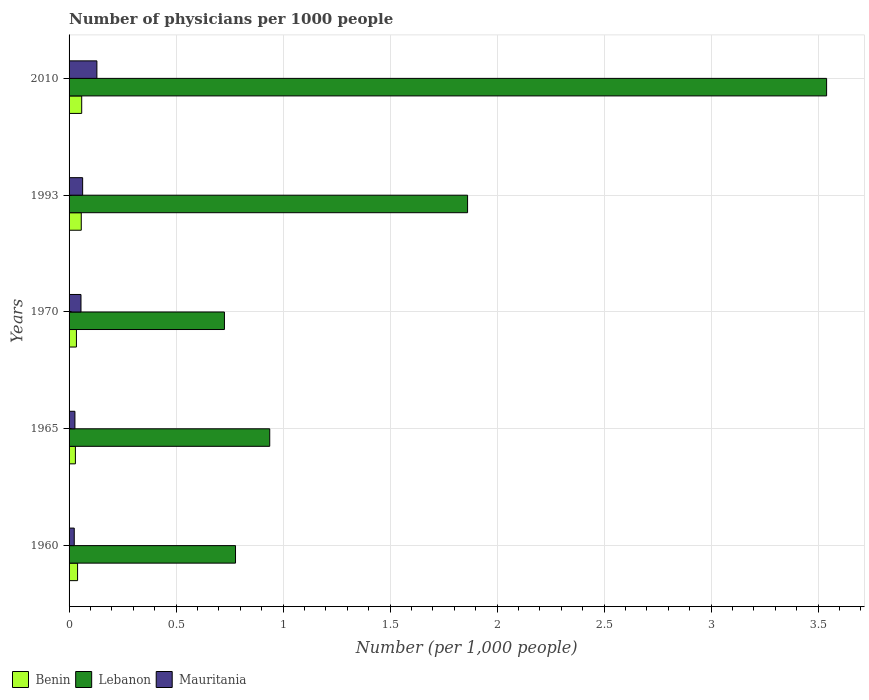How many groups of bars are there?
Give a very brief answer. 5. Are the number of bars per tick equal to the number of legend labels?
Provide a succinct answer. Yes. How many bars are there on the 5th tick from the bottom?
Ensure brevity in your answer.  3. What is the number of physicians in Mauritania in 1970?
Make the answer very short. 0.06. Across all years, what is the maximum number of physicians in Lebanon?
Your answer should be very brief. 3.54. Across all years, what is the minimum number of physicians in Benin?
Ensure brevity in your answer.  0.03. What is the total number of physicians in Mauritania in the graph?
Your answer should be very brief. 0.3. What is the difference between the number of physicians in Mauritania in 1965 and that in 1970?
Ensure brevity in your answer.  -0.03. What is the difference between the number of physicians in Mauritania in 1970 and the number of physicians in Lebanon in 1960?
Your answer should be compact. -0.72. What is the average number of physicians in Lebanon per year?
Your response must be concise. 1.57. In the year 1960, what is the difference between the number of physicians in Benin and number of physicians in Lebanon?
Offer a very short reply. -0.74. What is the ratio of the number of physicians in Mauritania in 1960 to that in 2010?
Ensure brevity in your answer.  0.19. What is the difference between the highest and the second highest number of physicians in Lebanon?
Give a very brief answer. 1.68. What is the difference between the highest and the lowest number of physicians in Benin?
Offer a terse response. 0.03. What does the 2nd bar from the top in 1960 represents?
Offer a very short reply. Lebanon. What does the 1st bar from the bottom in 2010 represents?
Keep it short and to the point. Benin. Is it the case that in every year, the sum of the number of physicians in Mauritania and number of physicians in Benin is greater than the number of physicians in Lebanon?
Your answer should be compact. No. How many bars are there?
Provide a short and direct response. 15. Are all the bars in the graph horizontal?
Provide a short and direct response. Yes. How many years are there in the graph?
Offer a terse response. 5. Are the values on the major ticks of X-axis written in scientific E-notation?
Give a very brief answer. No. Does the graph contain grids?
Offer a very short reply. Yes. How are the legend labels stacked?
Your response must be concise. Horizontal. What is the title of the graph?
Your response must be concise. Number of physicians per 1000 people. What is the label or title of the X-axis?
Provide a succinct answer. Number (per 1,0 people). What is the Number (per 1,000 people) of Benin in 1960?
Your answer should be compact. 0.04. What is the Number (per 1,000 people) of Lebanon in 1960?
Offer a terse response. 0.78. What is the Number (per 1,000 people) of Mauritania in 1960?
Provide a short and direct response. 0.02. What is the Number (per 1,000 people) of Benin in 1965?
Offer a terse response. 0.03. What is the Number (per 1,000 people) of Lebanon in 1965?
Your answer should be compact. 0.94. What is the Number (per 1,000 people) of Mauritania in 1965?
Provide a short and direct response. 0.03. What is the Number (per 1,000 people) in Benin in 1970?
Your response must be concise. 0.03. What is the Number (per 1,000 people) of Lebanon in 1970?
Make the answer very short. 0.73. What is the Number (per 1,000 people) in Mauritania in 1970?
Keep it short and to the point. 0.06. What is the Number (per 1,000 people) of Benin in 1993?
Your response must be concise. 0.06. What is the Number (per 1,000 people) of Lebanon in 1993?
Provide a succinct answer. 1.86. What is the Number (per 1,000 people) in Mauritania in 1993?
Give a very brief answer. 0.06. What is the Number (per 1,000 people) of Benin in 2010?
Your response must be concise. 0.06. What is the Number (per 1,000 people) of Lebanon in 2010?
Your answer should be very brief. 3.54. What is the Number (per 1,000 people) of Mauritania in 2010?
Your answer should be compact. 0.13. Across all years, what is the maximum Number (per 1,000 people) of Benin?
Ensure brevity in your answer.  0.06. Across all years, what is the maximum Number (per 1,000 people) of Lebanon?
Your answer should be very brief. 3.54. Across all years, what is the maximum Number (per 1,000 people) in Mauritania?
Ensure brevity in your answer.  0.13. Across all years, what is the minimum Number (per 1,000 people) of Benin?
Your answer should be very brief. 0.03. Across all years, what is the minimum Number (per 1,000 people) in Lebanon?
Keep it short and to the point. 0.73. Across all years, what is the minimum Number (per 1,000 people) of Mauritania?
Your response must be concise. 0.02. What is the total Number (per 1,000 people) in Benin in the graph?
Your answer should be compact. 0.22. What is the total Number (per 1,000 people) of Lebanon in the graph?
Offer a very short reply. 7.84. What is the total Number (per 1,000 people) in Mauritania in the graph?
Your response must be concise. 0.3. What is the difference between the Number (per 1,000 people) of Benin in 1960 and that in 1965?
Give a very brief answer. 0.01. What is the difference between the Number (per 1,000 people) in Lebanon in 1960 and that in 1965?
Make the answer very short. -0.16. What is the difference between the Number (per 1,000 people) in Mauritania in 1960 and that in 1965?
Offer a very short reply. -0. What is the difference between the Number (per 1,000 people) of Benin in 1960 and that in 1970?
Your answer should be compact. 0.01. What is the difference between the Number (per 1,000 people) in Lebanon in 1960 and that in 1970?
Your answer should be very brief. 0.05. What is the difference between the Number (per 1,000 people) of Mauritania in 1960 and that in 1970?
Ensure brevity in your answer.  -0.03. What is the difference between the Number (per 1,000 people) in Benin in 1960 and that in 1993?
Your response must be concise. -0.02. What is the difference between the Number (per 1,000 people) of Lebanon in 1960 and that in 1993?
Your answer should be very brief. -1.08. What is the difference between the Number (per 1,000 people) of Mauritania in 1960 and that in 1993?
Give a very brief answer. -0.04. What is the difference between the Number (per 1,000 people) in Benin in 1960 and that in 2010?
Your answer should be very brief. -0.02. What is the difference between the Number (per 1,000 people) of Lebanon in 1960 and that in 2010?
Give a very brief answer. -2.76. What is the difference between the Number (per 1,000 people) of Mauritania in 1960 and that in 2010?
Your answer should be compact. -0.11. What is the difference between the Number (per 1,000 people) of Benin in 1965 and that in 1970?
Your answer should be compact. -0. What is the difference between the Number (per 1,000 people) in Lebanon in 1965 and that in 1970?
Your answer should be very brief. 0.21. What is the difference between the Number (per 1,000 people) in Mauritania in 1965 and that in 1970?
Your answer should be very brief. -0.03. What is the difference between the Number (per 1,000 people) in Benin in 1965 and that in 1993?
Ensure brevity in your answer.  -0.03. What is the difference between the Number (per 1,000 people) of Lebanon in 1965 and that in 1993?
Provide a succinct answer. -0.92. What is the difference between the Number (per 1,000 people) of Mauritania in 1965 and that in 1993?
Provide a succinct answer. -0.04. What is the difference between the Number (per 1,000 people) in Benin in 1965 and that in 2010?
Your answer should be compact. -0.03. What is the difference between the Number (per 1,000 people) of Lebanon in 1965 and that in 2010?
Make the answer very short. -2.6. What is the difference between the Number (per 1,000 people) in Mauritania in 1965 and that in 2010?
Offer a terse response. -0.1. What is the difference between the Number (per 1,000 people) of Benin in 1970 and that in 1993?
Give a very brief answer. -0.02. What is the difference between the Number (per 1,000 people) of Lebanon in 1970 and that in 1993?
Provide a short and direct response. -1.14. What is the difference between the Number (per 1,000 people) of Mauritania in 1970 and that in 1993?
Ensure brevity in your answer.  -0.01. What is the difference between the Number (per 1,000 people) of Benin in 1970 and that in 2010?
Give a very brief answer. -0.02. What is the difference between the Number (per 1,000 people) in Lebanon in 1970 and that in 2010?
Keep it short and to the point. -2.81. What is the difference between the Number (per 1,000 people) in Mauritania in 1970 and that in 2010?
Keep it short and to the point. -0.07. What is the difference between the Number (per 1,000 people) in Benin in 1993 and that in 2010?
Your response must be concise. -0. What is the difference between the Number (per 1,000 people) of Lebanon in 1993 and that in 2010?
Make the answer very short. -1.68. What is the difference between the Number (per 1,000 people) in Mauritania in 1993 and that in 2010?
Your answer should be very brief. -0.07. What is the difference between the Number (per 1,000 people) in Benin in 1960 and the Number (per 1,000 people) in Lebanon in 1965?
Provide a short and direct response. -0.9. What is the difference between the Number (per 1,000 people) in Benin in 1960 and the Number (per 1,000 people) in Mauritania in 1965?
Make the answer very short. 0.01. What is the difference between the Number (per 1,000 people) in Lebanon in 1960 and the Number (per 1,000 people) in Mauritania in 1965?
Ensure brevity in your answer.  0.75. What is the difference between the Number (per 1,000 people) in Benin in 1960 and the Number (per 1,000 people) in Lebanon in 1970?
Ensure brevity in your answer.  -0.69. What is the difference between the Number (per 1,000 people) in Benin in 1960 and the Number (per 1,000 people) in Mauritania in 1970?
Your answer should be very brief. -0.02. What is the difference between the Number (per 1,000 people) in Lebanon in 1960 and the Number (per 1,000 people) in Mauritania in 1970?
Make the answer very short. 0.72. What is the difference between the Number (per 1,000 people) in Benin in 1960 and the Number (per 1,000 people) in Lebanon in 1993?
Ensure brevity in your answer.  -1.82. What is the difference between the Number (per 1,000 people) in Benin in 1960 and the Number (per 1,000 people) in Mauritania in 1993?
Your response must be concise. -0.02. What is the difference between the Number (per 1,000 people) of Lebanon in 1960 and the Number (per 1,000 people) of Mauritania in 1993?
Provide a succinct answer. 0.71. What is the difference between the Number (per 1,000 people) in Benin in 1960 and the Number (per 1,000 people) in Lebanon in 2010?
Your answer should be very brief. -3.5. What is the difference between the Number (per 1,000 people) of Benin in 1960 and the Number (per 1,000 people) of Mauritania in 2010?
Keep it short and to the point. -0.09. What is the difference between the Number (per 1,000 people) in Lebanon in 1960 and the Number (per 1,000 people) in Mauritania in 2010?
Offer a very short reply. 0.65. What is the difference between the Number (per 1,000 people) in Benin in 1965 and the Number (per 1,000 people) in Lebanon in 1970?
Offer a terse response. -0.7. What is the difference between the Number (per 1,000 people) in Benin in 1965 and the Number (per 1,000 people) in Mauritania in 1970?
Ensure brevity in your answer.  -0.03. What is the difference between the Number (per 1,000 people) in Lebanon in 1965 and the Number (per 1,000 people) in Mauritania in 1970?
Provide a succinct answer. 0.88. What is the difference between the Number (per 1,000 people) in Benin in 1965 and the Number (per 1,000 people) in Lebanon in 1993?
Your answer should be very brief. -1.83. What is the difference between the Number (per 1,000 people) of Benin in 1965 and the Number (per 1,000 people) of Mauritania in 1993?
Your response must be concise. -0.03. What is the difference between the Number (per 1,000 people) of Lebanon in 1965 and the Number (per 1,000 people) of Mauritania in 1993?
Provide a short and direct response. 0.87. What is the difference between the Number (per 1,000 people) of Benin in 1965 and the Number (per 1,000 people) of Lebanon in 2010?
Offer a terse response. -3.51. What is the difference between the Number (per 1,000 people) in Benin in 1965 and the Number (per 1,000 people) in Mauritania in 2010?
Offer a terse response. -0.1. What is the difference between the Number (per 1,000 people) in Lebanon in 1965 and the Number (per 1,000 people) in Mauritania in 2010?
Make the answer very short. 0.81. What is the difference between the Number (per 1,000 people) of Benin in 1970 and the Number (per 1,000 people) of Lebanon in 1993?
Give a very brief answer. -1.83. What is the difference between the Number (per 1,000 people) in Benin in 1970 and the Number (per 1,000 people) in Mauritania in 1993?
Keep it short and to the point. -0.03. What is the difference between the Number (per 1,000 people) of Lebanon in 1970 and the Number (per 1,000 people) of Mauritania in 1993?
Make the answer very short. 0.66. What is the difference between the Number (per 1,000 people) of Benin in 1970 and the Number (per 1,000 people) of Lebanon in 2010?
Ensure brevity in your answer.  -3.51. What is the difference between the Number (per 1,000 people) of Benin in 1970 and the Number (per 1,000 people) of Mauritania in 2010?
Provide a succinct answer. -0.1. What is the difference between the Number (per 1,000 people) in Lebanon in 1970 and the Number (per 1,000 people) in Mauritania in 2010?
Your response must be concise. 0.6. What is the difference between the Number (per 1,000 people) in Benin in 1993 and the Number (per 1,000 people) in Lebanon in 2010?
Your answer should be very brief. -3.48. What is the difference between the Number (per 1,000 people) in Benin in 1993 and the Number (per 1,000 people) in Mauritania in 2010?
Offer a very short reply. -0.07. What is the difference between the Number (per 1,000 people) of Lebanon in 1993 and the Number (per 1,000 people) of Mauritania in 2010?
Give a very brief answer. 1.73. What is the average Number (per 1,000 people) in Benin per year?
Ensure brevity in your answer.  0.04. What is the average Number (per 1,000 people) in Lebanon per year?
Offer a very short reply. 1.57. What is the average Number (per 1,000 people) in Mauritania per year?
Provide a short and direct response. 0.06. In the year 1960, what is the difference between the Number (per 1,000 people) of Benin and Number (per 1,000 people) of Lebanon?
Your response must be concise. -0.74. In the year 1960, what is the difference between the Number (per 1,000 people) in Benin and Number (per 1,000 people) in Mauritania?
Your answer should be very brief. 0.02. In the year 1960, what is the difference between the Number (per 1,000 people) of Lebanon and Number (per 1,000 people) of Mauritania?
Keep it short and to the point. 0.75. In the year 1965, what is the difference between the Number (per 1,000 people) of Benin and Number (per 1,000 people) of Lebanon?
Give a very brief answer. -0.91. In the year 1965, what is the difference between the Number (per 1,000 people) in Benin and Number (per 1,000 people) in Mauritania?
Offer a very short reply. 0. In the year 1965, what is the difference between the Number (per 1,000 people) in Lebanon and Number (per 1,000 people) in Mauritania?
Provide a succinct answer. 0.91. In the year 1970, what is the difference between the Number (per 1,000 people) in Benin and Number (per 1,000 people) in Lebanon?
Make the answer very short. -0.69. In the year 1970, what is the difference between the Number (per 1,000 people) of Benin and Number (per 1,000 people) of Mauritania?
Make the answer very short. -0.02. In the year 1970, what is the difference between the Number (per 1,000 people) of Lebanon and Number (per 1,000 people) of Mauritania?
Your answer should be very brief. 0.67. In the year 1993, what is the difference between the Number (per 1,000 people) in Benin and Number (per 1,000 people) in Lebanon?
Provide a short and direct response. -1.81. In the year 1993, what is the difference between the Number (per 1,000 people) in Benin and Number (per 1,000 people) in Mauritania?
Give a very brief answer. -0.01. In the year 1993, what is the difference between the Number (per 1,000 people) in Lebanon and Number (per 1,000 people) in Mauritania?
Give a very brief answer. 1.8. In the year 2010, what is the difference between the Number (per 1,000 people) of Benin and Number (per 1,000 people) of Lebanon?
Your response must be concise. -3.48. In the year 2010, what is the difference between the Number (per 1,000 people) of Benin and Number (per 1,000 people) of Mauritania?
Offer a very short reply. -0.07. In the year 2010, what is the difference between the Number (per 1,000 people) in Lebanon and Number (per 1,000 people) in Mauritania?
Keep it short and to the point. 3.41. What is the ratio of the Number (per 1,000 people) of Benin in 1960 to that in 1965?
Your response must be concise. 1.34. What is the ratio of the Number (per 1,000 people) of Lebanon in 1960 to that in 1965?
Make the answer very short. 0.83. What is the ratio of the Number (per 1,000 people) of Mauritania in 1960 to that in 1965?
Ensure brevity in your answer.  0.88. What is the ratio of the Number (per 1,000 people) in Benin in 1960 to that in 1970?
Your response must be concise. 1.16. What is the ratio of the Number (per 1,000 people) in Lebanon in 1960 to that in 1970?
Offer a terse response. 1.07. What is the ratio of the Number (per 1,000 people) in Mauritania in 1960 to that in 1970?
Your answer should be very brief. 0.43. What is the ratio of the Number (per 1,000 people) in Benin in 1960 to that in 1993?
Offer a terse response. 0.7. What is the ratio of the Number (per 1,000 people) of Lebanon in 1960 to that in 1993?
Keep it short and to the point. 0.42. What is the ratio of the Number (per 1,000 people) of Mauritania in 1960 to that in 1993?
Provide a succinct answer. 0.38. What is the ratio of the Number (per 1,000 people) in Benin in 1960 to that in 2010?
Your response must be concise. 0.67. What is the ratio of the Number (per 1,000 people) in Lebanon in 1960 to that in 2010?
Provide a short and direct response. 0.22. What is the ratio of the Number (per 1,000 people) in Mauritania in 1960 to that in 2010?
Provide a succinct answer. 0.19. What is the ratio of the Number (per 1,000 people) in Benin in 1965 to that in 1970?
Offer a very short reply. 0.86. What is the ratio of the Number (per 1,000 people) in Lebanon in 1965 to that in 1970?
Provide a short and direct response. 1.29. What is the ratio of the Number (per 1,000 people) in Mauritania in 1965 to that in 1970?
Your answer should be compact. 0.49. What is the ratio of the Number (per 1,000 people) in Benin in 1965 to that in 1993?
Provide a short and direct response. 0.52. What is the ratio of the Number (per 1,000 people) of Lebanon in 1965 to that in 1993?
Your answer should be very brief. 0.5. What is the ratio of the Number (per 1,000 people) in Mauritania in 1965 to that in 1993?
Offer a very short reply. 0.43. What is the ratio of the Number (per 1,000 people) of Benin in 1965 to that in 2010?
Your answer should be very brief. 0.5. What is the ratio of the Number (per 1,000 people) of Lebanon in 1965 to that in 2010?
Offer a terse response. 0.26. What is the ratio of the Number (per 1,000 people) of Mauritania in 1965 to that in 2010?
Provide a succinct answer. 0.21. What is the ratio of the Number (per 1,000 people) in Benin in 1970 to that in 1993?
Make the answer very short. 0.6. What is the ratio of the Number (per 1,000 people) in Lebanon in 1970 to that in 1993?
Offer a very short reply. 0.39. What is the ratio of the Number (per 1,000 people) in Mauritania in 1970 to that in 1993?
Your answer should be very brief. 0.88. What is the ratio of the Number (per 1,000 people) of Benin in 1970 to that in 2010?
Offer a very short reply. 0.58. What is the ratio of the Number (per 1,000 people) in Lebanon in 1970 to that in 2010?
Ensure brevity in your answer.  0.21. What is the ratio of the Number (per 1,000 people) in Mauritania in 1970 to that in 2010?
Offer a terse response. 0.43. What is the ratio of the Number (per 1,000 people) in Benin in 1993 to that in 2010?
Provide a short and direct response. 0.97. What is the ratio of the Number (per 1,000 people) in Lebanon in 1993 to that in 2010?
Your answer should be compact. 0.53. What is the ratio of the Number (per 1,000 people) of Mauritania in 1993 to that in 2010?
Offer a terse response. 0.49. What is the difference between the highest and the second highest Number (per 1,000 people) in Benin?
Offer a terse response. 0. What is the difference between the highest and the second highest Number (per 1,000 people) of Lebanon?
Your answer should be compact. 1.68. What is the difference between the highest and the second highest Number (per 1,000 people) in Mauritania?
Give a very brief answer. 0.07. What is the difference between the highest and the lowest Number (per 1,000 people) of Benin?
Offer a terse response. 0.03. What is the difference between the highest and the lowest Number (per 1,000 people) of Lebanon?
Offer a terse response. 2.81. What is the difference between the highest and the lowest Number (per 1,000 people) in Mauritania?
Give a very brief answer. 0.11. 